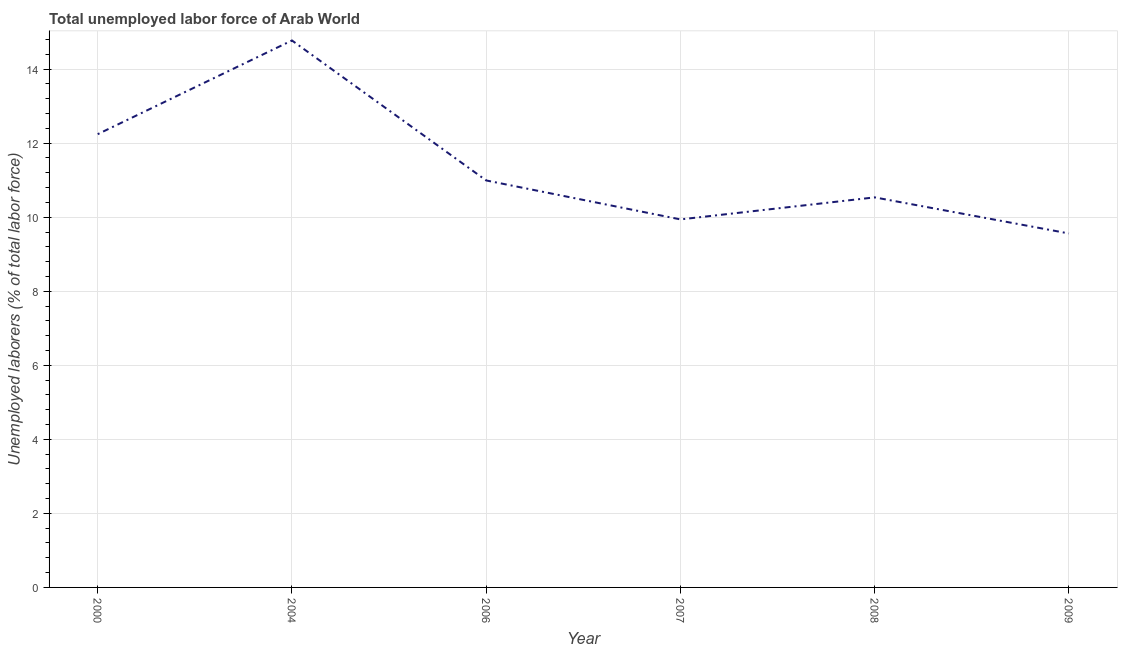What is the total unemployed labour force in 2006?
Ensure brevity in your answer.  10.99. Across all years, what is the maximum total unemployed labour force?
Offer a very short reply. 14.77. Across all years, what is the minimum total unemployed labour force?
Provide a short and direct response. 9.56. In which year was the total unemployed labour force maximum?
Provide a short and direct response. 2004. What is the sum of the total unemployed labour force?
Offer a terse response. 68.04. What is the difference between the total unemployed labour force in 2000 and 2007?
Give a very brief answer. 2.3. What is the average total unemployed labour force per year?
Provide a succinct answer. 11.34. What is the median total unemployed labour force?
Your response must be concise. 10.76. In how many years, is the total unemployed labour force greater than 4 %?
Keep it short and to the point. 6. Do a majority of the years between 2000 and 2008 (inclusive) have total unemployed labour force greater than 10 %?
Your response must be concise. Yes. What is the ratio of the total unemployed labour force in 2000 to that in 2008?
Your answer should be compact. 1.16. What is the difference between the highest and the second highest total unemployed labour force?
Provide a short and direct response. 2.53. What is the difference between the highest and the lowest total unemployed labour force?
Offer a very short reply. 5.21. In how many years, is the total unemployed labour force greater than the average total unemployed labour force taken over all years?
Keep it short and to the point. 2. How many years are there in the graph?
Offer a terse response. 6. What is the difference between two consecutive major ticks on the Y-axis?
Keep it short and to the point. 2. Are the values on the major ticks of Y-axis written in scientific E-notation?
Offer a very short reply. No. Does the graph contain any zero values?
Provide a short and direct response. No. Does the graph contain grids?
Your answer should be very brief. Yes. What is the title of the graph?
Provide a short and direct response. Total unemployed labor force of Arab World. What is the label or title of the X-axis?
Keep it short and to the point. Year. What is the label or title of the Y-axis?
Make the answer very short. Unemployed laborers (% of total labor force). What is the Unemployed laborers (% of total labor force) of 2000?
Offer a very short reply. 12.24. What is the Unemployed laborers (% of total labor force) in 2004?
Your answer should be very brief. 14.77. What is the Unemployed laborers (% of total labor force) of 2006?
Offer a very short reply. 10.99. What is the Unemployed laborers (% of total labor force) in 2007?
Your response must be concise. 9.94. What is the Unemployed laborers (% of total labor force) in 2008?
Give a very brief answer. 10.54. What is the Unemployed laborers (% of total labor force) in 2009?
Provide a short and direct response. 9.56. What is the difference between the Unemployed laborers (% of total labor force) in 2000 and 2004?
Give a very brief answer. -2.53. What is the difference between the Unemployed laborers (% of total labor force) in 2000 and 2006?
Provide a short and direct response. 1.25. What is the difference between the Unemployed laborers (% of total labor force) in 2000 and 2007?
Your response must be concise. 2.3. What is the difference between the Unemployed laborers (% of total labor force) in 2000 and 2008?
Make the answer very short. 1.71. What is the difference between the Unemployed laborers (% of total labor force) in 2000 and 2009?
Provide a succinct answer. 2.68. What is the difference between the Unemployed laborers (% of total labor force) in 2004 and 2006?
Ensure brevity in your answer.  3.78. What is the difference between the Unemployed laborers (% of total labor force) in 2004 and 2007?
Give a very brief answer. 4.83. What is the difference between the Unemployed laborers (% of total labor force) in 2004 and 2008?
Give a very brief answer. 4.24. What is the difference between the Unemployed laborers (% of total labor force) in 2004 and 2009?
Ensure brevity in your answer.  5.21. What is the difference between the Unemployed laborers (% of total labor force) in 2006 and 2007?
Make the answer very short. 1.05. What is the difference between the Unemployed laborers (% of total labor force) in 2006 and 2008?
Provide a short and direct response. 0.46. What is the difference between the Unemployed laborers (% of total labor force) in 2006 and 2009?
Offer a terse response. 1.43. What is the difference between the Unemployed laborers (% of total labor force) in 2007 and 2008?
Offer a terse response. -0.59. What is the difference between the Unemployed laborers (% of total labor force) in 2007 and 2009?
Provide a short and direct response. 0.38. What is the difference between the Unemployed laborers (% of total labor force) in 2008 and 2009?
Provide a succinct answer. 0.97. What is the ratio of the Unemployed laborers (% of total labor force) in 2000 to that in 2004?
Offer a very short reply. 0.83. What is the ratio of the Unemployed laborers (% of total labor force) in 2000 to that in 2006?
Ensure brevity in your answer.  1.11. What is the ratio of the Unemployed laborers (% of total labor force) in 2000 to that in 2007?
Keep it short and to the point. 1.23. What is the ratio of the Unemployed laborers (% of total labor force) in 2000 to that in 2008?
Give a very brief answer. 1.16. What is the ratio of the Unemployed laborers (% of total labor force) in 2000 to that in 2009?
Your answer should be very brief. 1.28. What is the ratio of the Unemployed laborers (% of total labor force) in 2004 to that in 2006?
Offer a terse response. 1.34. What is the ratio of the Unemployed laborers (% of total labor force) in 2004 to that in 2007?
Your answer should be compact. 1.49. What is the ratio of the Unemployed laborers (% of total labor force) in 2004 to that in 2008?
Offer a very short reply. 1.4. What is the ratio of the Unemployed laborers (% of total labor force) in 2004 to that in 2009?
Ensure brevity in your answer.  1.54. What is the ratio of the Unemployed laborers (% of total labor force) in 2006 to that in 2007?
Keep it short and to the point. 1.11. What is the ratio of the Unemployed laborers (% of total labor force) in 2006 to that in 2008?
Give a very brief answer. 1.04. What is the ratio of the Unemployed laborers (% of total labor force) in 2006 to that in 2009?
Make the answer very short. 1.15. What is the ratio of the Unemployed laborers (% of total labor force) in 2007 to that in 2008?
Offer a terse response. 0.94. What is the ratio of the Unemployed laborers (% of total labor force) in 2007 to that in 2009?
Your answer should be compact. 1.04. What is the ratio of the Unemployed laborers (% of total labor force) in 2008 to that in 2009?
Offer a very short reply. 1.1. 